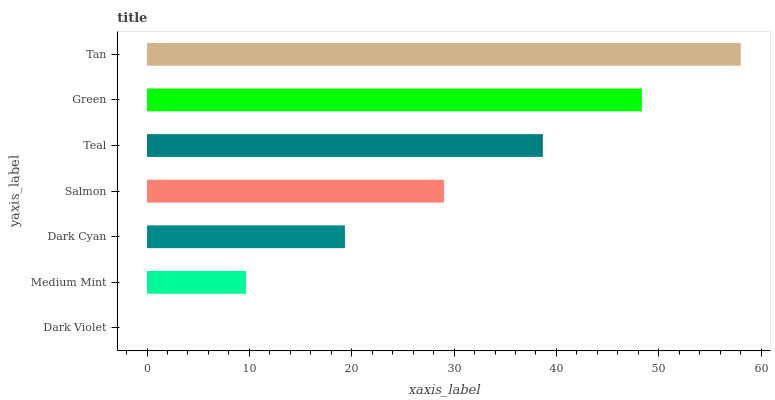Is Dark Violet the minimum?
Answer yes or no. Yes. Is Tan the maximum?
Answer yes or no. Yes. Is Medium Mint the minimum?
Answer yes or no. No. Is Medium Mint the maximum?
Answer yes or no. No. Is Medium Mint greater than Dark Violet?
Answer yes or no. Yes. Is Dark Violet less than Medium Mint?
Answer yes or no. Yes. Is Dark Violet greater than Medium Mint?
Answer yes or no. No. Is Medium Mint less than Dark Violet?
Answer yes or no. No. Is Salmon the high median?
Answer yes or no. Yes. Is Salmon the low median?
Answer yes or no. Yes. Is Teal the high median?
Answer yes or no. No. Is Dark Violet the low median?
Answer yes or no. No. 